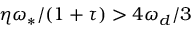<formula> <loc_0><loc_0><loc_500><loc_500>\eta \omega _ { \ast } / ( 1 + \tau ) > 4 \omega _ { d } / 3</formula> 